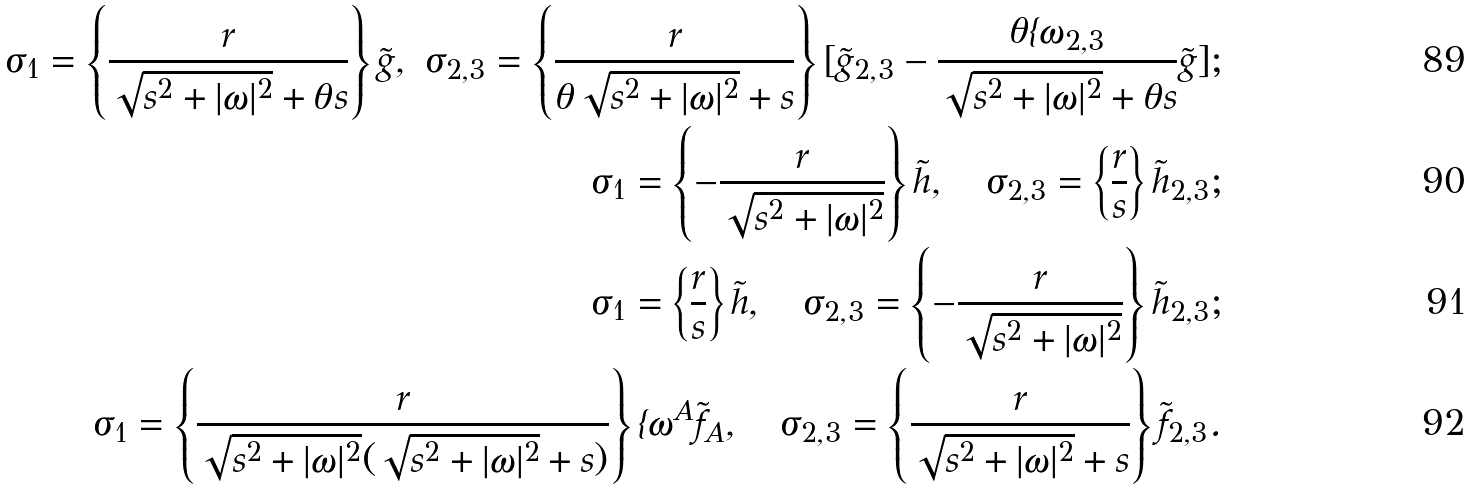Convert formula to latex. <formula><loc_0><loc_0><loc_500><loc_500>\sigma _ { 1 } = \left \{ \frac { r } { \sqrt { s ^ { 2 } + | \omega | ^ { 2 } } + \theta s } \right \} \tilde { g } , \ \sigma _ { 2 , 3 } = \left \{ \frac { r } { \theta \sqrt { s ^ { 2 } + | \omega | ^ { 2 } } + s } \right \} [ \tilde { g } _ { 2 , 3 } - \frac { \theta \imath \omega _ { 2 , 3 } } { \sqrt { s ^ { 2 } + | \omega | ^ { 2 } } + \theta s } \tilde { g } ] ; \\ \sigma _ { 1 } = \left \{ - \frac { r } { \sqrt { s ^ { 2 } + | \omega | ^ { 2 } } } \right \} \tilde { h } , \quad \sigma _ { 2 , 3 } = \left \{ \frac { r } { s } \right \} \tilde { h } _ { 2 , 3 } ; \\ \sigma _ { 1 } = \left \{ \frac { r } { s } \right \} \tilde { h } , \quad \sigma _ { 2 , 3 } = \left \{ - \frac { r } { \sqrt { s ^ { 2 } + | \omega | ^ { 2 } } } \right \} \tilde { h } _ { 2 , 3 } ; \\ \sigma _ { 1 } = \left \{ \frac { r } { \sqrt { s ^ { 2 } + | \omega | ^ { 2 } } ( \sqrt { s ^ { 2 } + | \omega | ^ { 2 } } + s ) } \right \} \imath \omega ^ { A } \tilde { f } _ { A } , \quad \sigma _ { 2 , 3 } = \left \{ \frac { r } { \sqrt { s ^ { 2 } + | \omega | ^ { 2 } } + s } \right \} \tilde { f } _ { 2 , 3 } .</formula> 